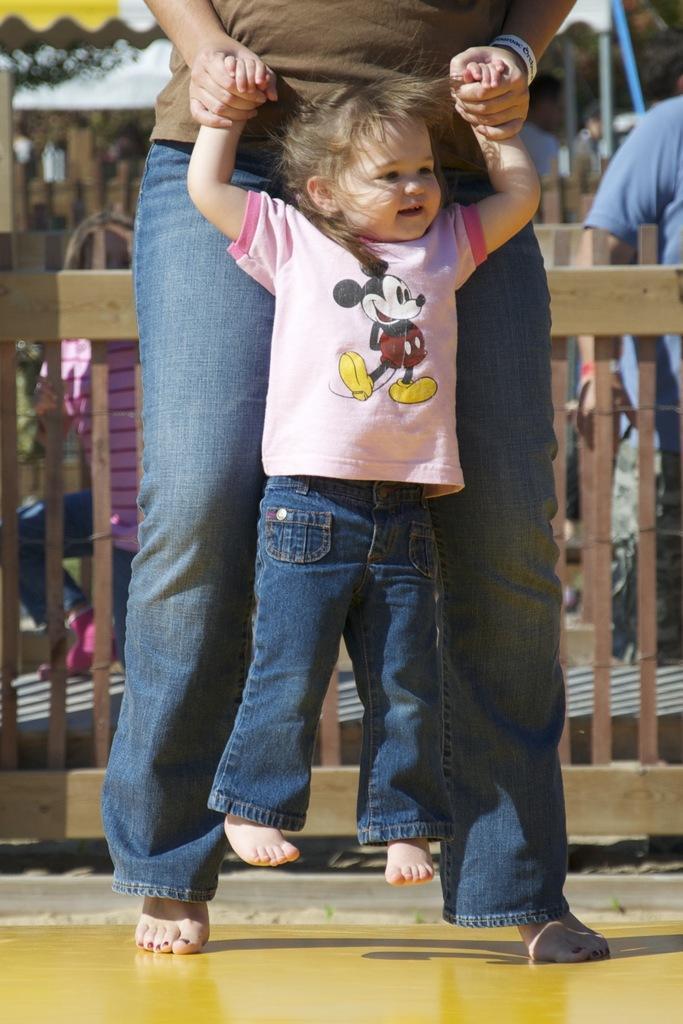How would you summarize this image in a sentence or two? In this picture I can observe a girl in the middle of the picture. There is a person holding this girl. In the background I can observe wooden railing. 